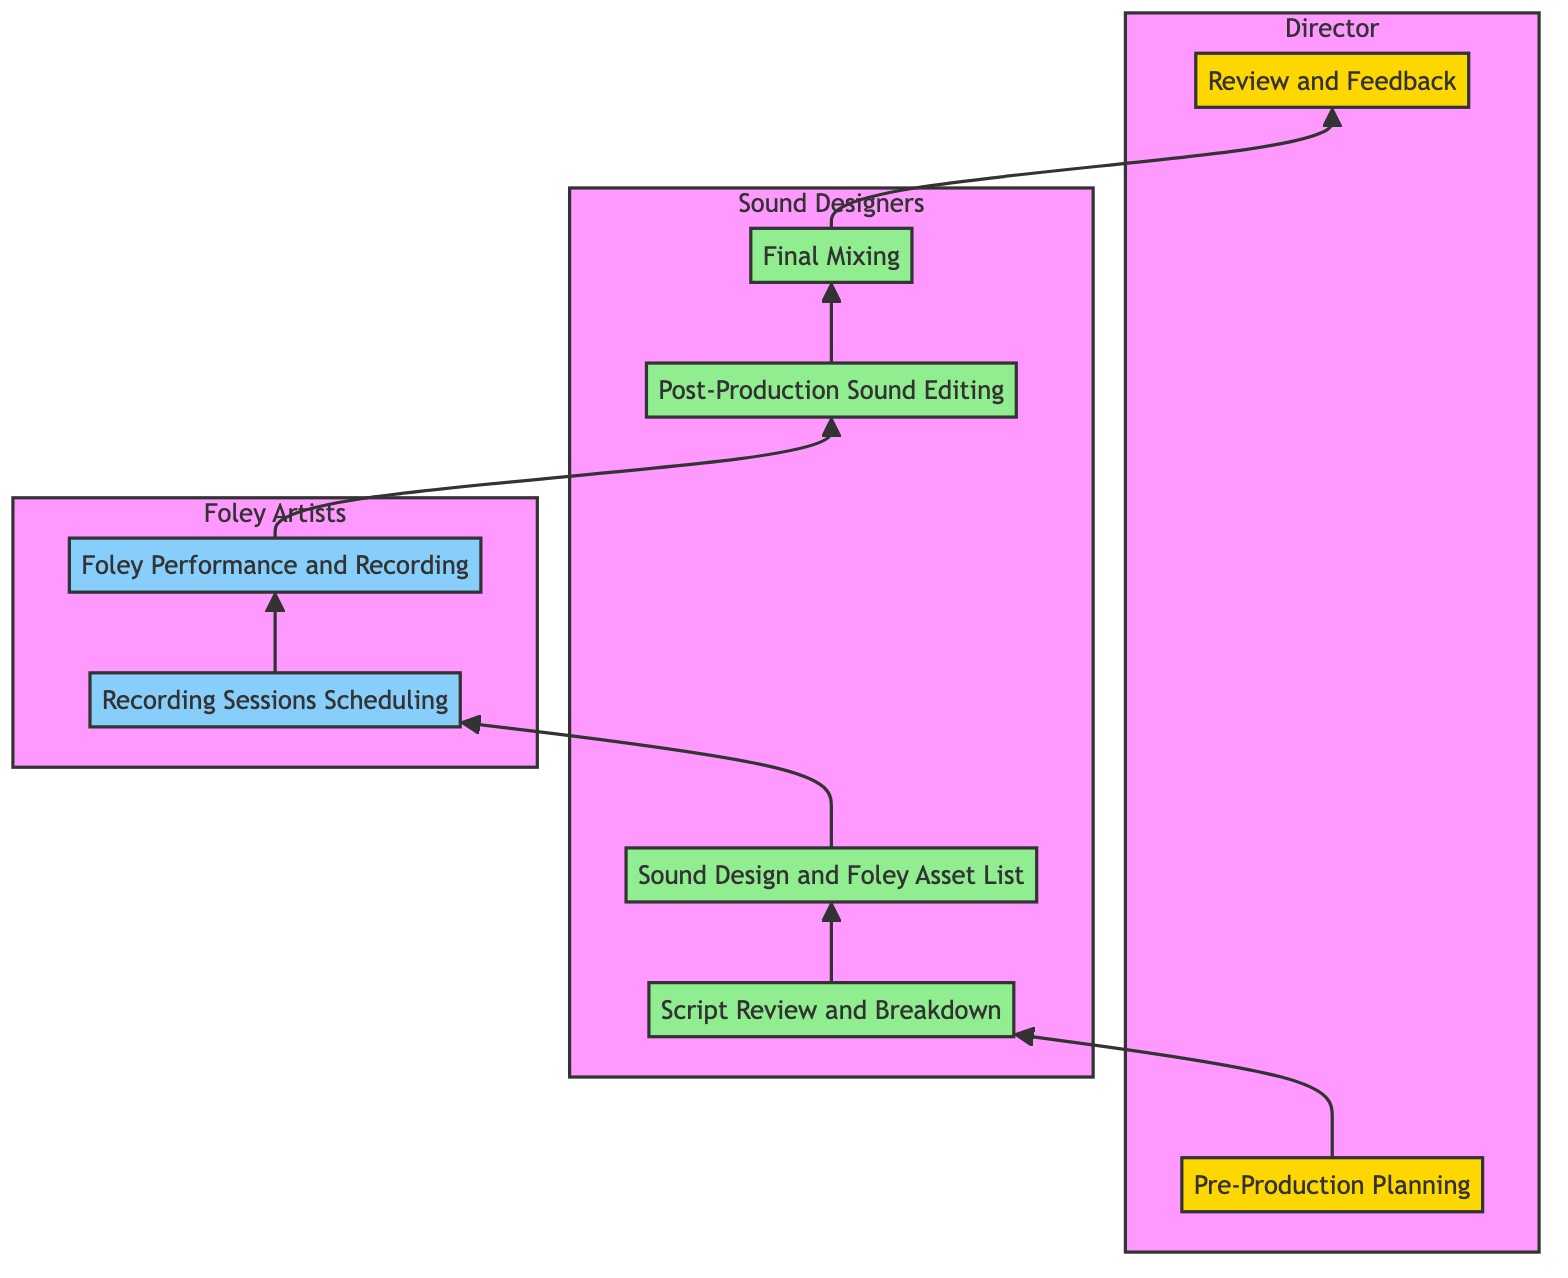What is the first step in the collaboration workflow? The first step listed in the diagram is "Pre-Production Planning." It is at the bottom of the flowchart and serves as the starting point of the collaboration process.
Answer: Pre-Production Planning How many roles are involved in "Sound Design and Foley Asset List"? The node "Sound Design and Foley Asset List" is directly connected to two roles: Sound Designers and Foley Artists, both of whom collaborate at this stage.
Answer: 2 Which step comes after "Recording Sessions Scheduling"? After "Recording Sessions Scheduling," the next step indicated in the diagram is "Foley Performance and Recording." This follows the workflow sequence upwards.
Answer: Foley Performance and Recording How many total steps are there in the collaboration workflow? There are a total of eight steps listed in the diagram, from "Pre-Production Planning" to "Review and Feedback." Each step represents a phase in the collaboration workflow.
Answer: 8 What is the relationship between Directors and Sound Designers? The relationship between Directors and Sound Designers is established in three places: during "Pre-Production Planning," "Post-Production Sound Editing," and "Final Mixing." Directors work with Sound Designers at each of these points.
Answer: Collaborators What is the last step before final feedback from the Director? The last step before the Director provides feedback is "Final Mixing." This is where all sound elements are balanced and fine-tuned, signaling the completion of the sound design before review.
Answer: Final Mixing Which two roles collaborate during the "Foley Performance and Recording"? The two roles that collaborate during "Foley Performance and Recording" are Foley Artists and Sound Designers. This step requires their joint efforts to achieve the desired sound effects.
Answer: Foley Artists, Sound Designers What step directly precedes "Post-Production Sound Editing"? The step directly preceding "Post-Production Sound Editing" is "Foley Performance and Recording." This shows the sequence of events leading to editing in the workflow.
Answer: Foley Performance and Recording Which stage is located at the top of the flowchart? The top stage in the flowchart is "Review and Feedback." It represents the final stage of the collaboration workflow where the Director reviews the work produced by the team.
Answer: Review and Feedback 